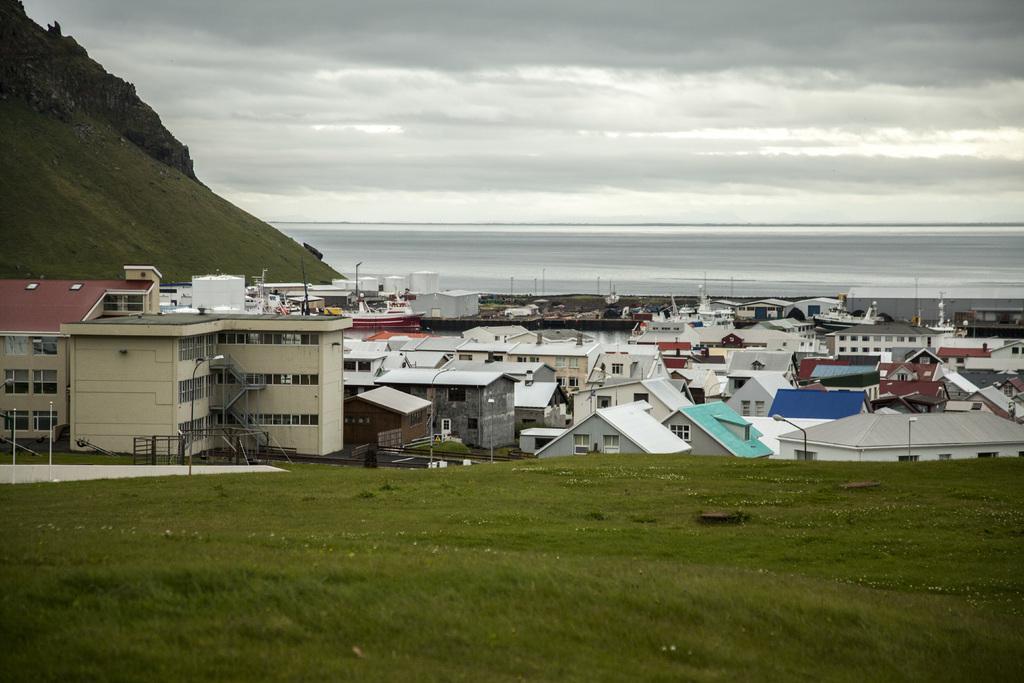Could you give a brief overview of what you see in this image? In this image, there is an outside view. There are some buildings in the middle of the image. There is a hill in the top left of the image. There is a sky at the top of the image. 